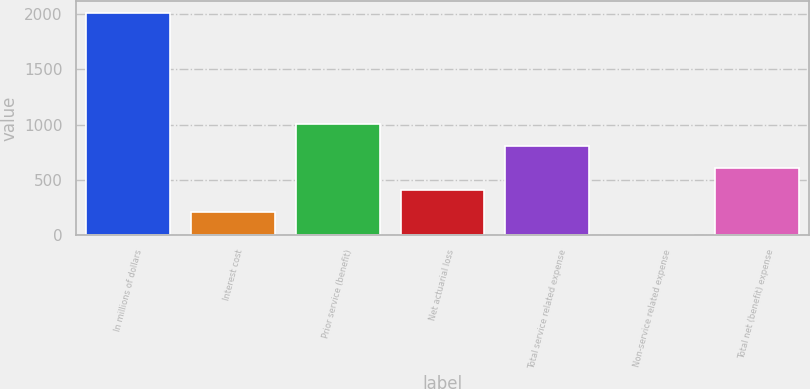Convert chart. <chart><loc_0><loc_0><loc_500><loc_500><bar_chart><fcel>In millions of dollars<fcel>Interest cost<fcel>Prior service (benefit)<fcel>Net actuarial loss<fcel>Total service related expense<fcel>Non-service related expense<fcel>Total net (benefit) expense<nl><fcel>2015<fcel>204.2<fcel>1009<fcel>405.4<fcel>807.8<fcel>3<fcel>606.6<nl></chart> 